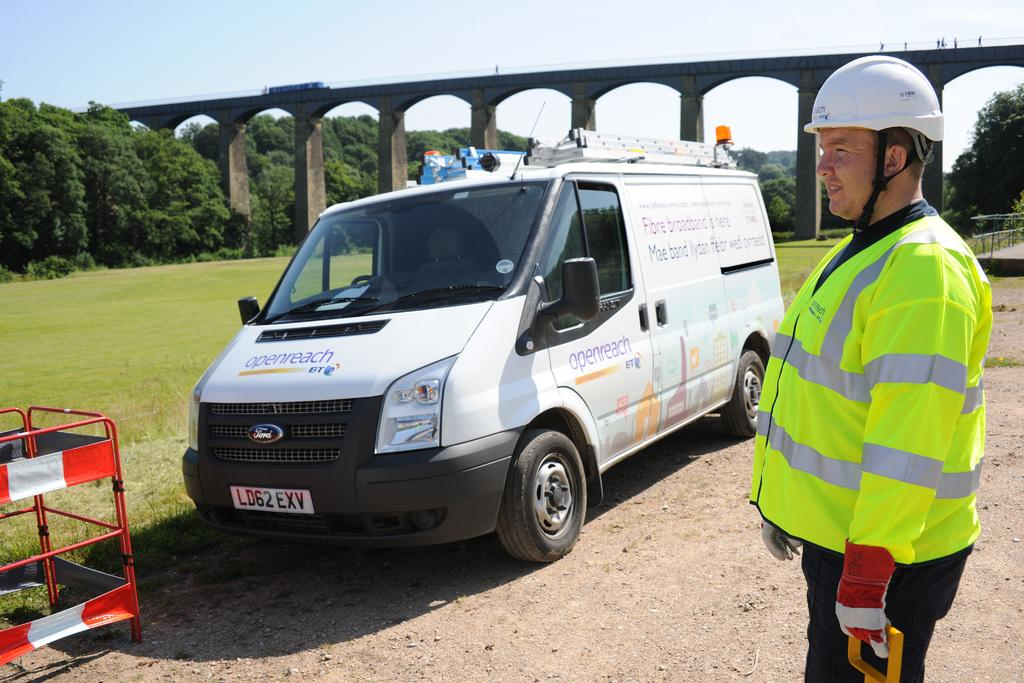<image>
Share a concise interpretation of the image provided. a van with the label openreach on the front of it 